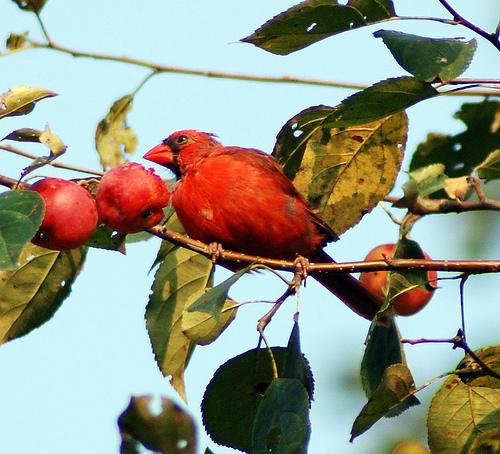Which states in the US is this species indigenous to?
Write a very short answer. Ohio. What color are the leaves?
Short answer required. Green. What kind of bird is this?
Write a very short answer. Cardinal. 